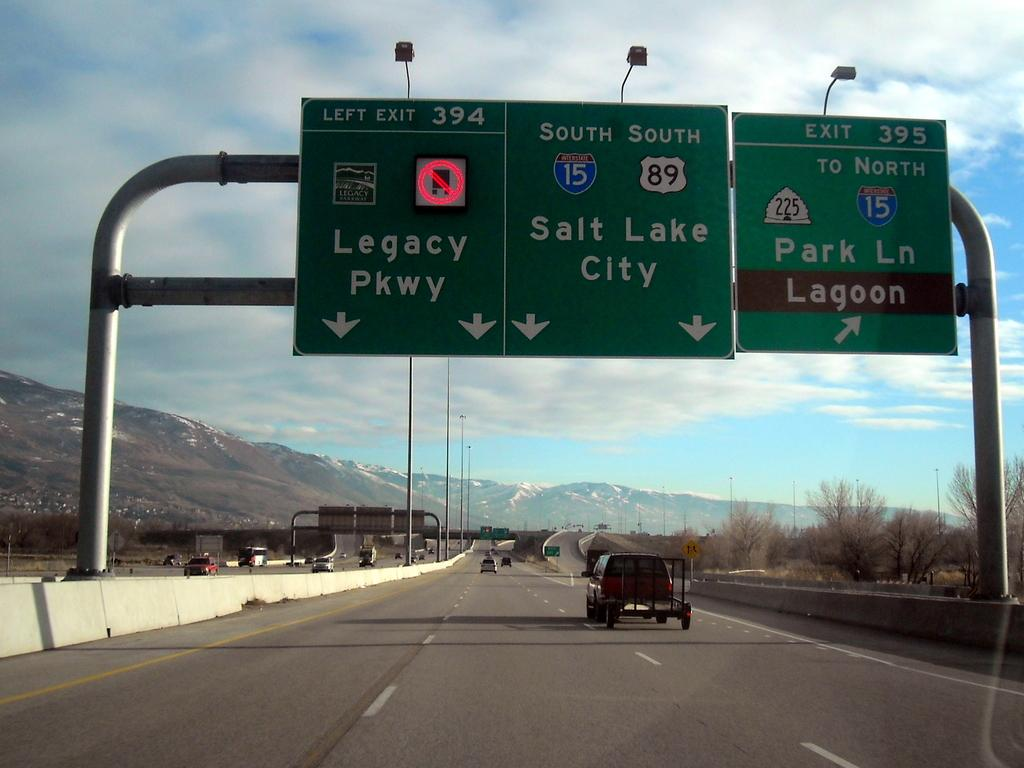<image>
Relay a brief, clear account of the picture shown. The freeway signs indicate that Park Ln is the next exit on the right. 